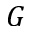Convert formula to latex. <formula><loc_0><loc_0><loc_500><loc_500>G</formula> 